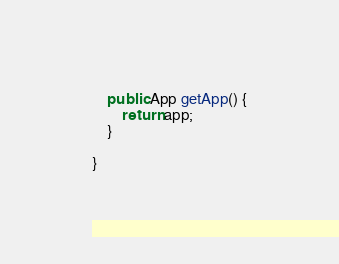Convert code to text. <code><loc_0><loc_0><loc_500><loc_500><_Java_>
    public App getApp() {
        return app;
    }

}
</code> 